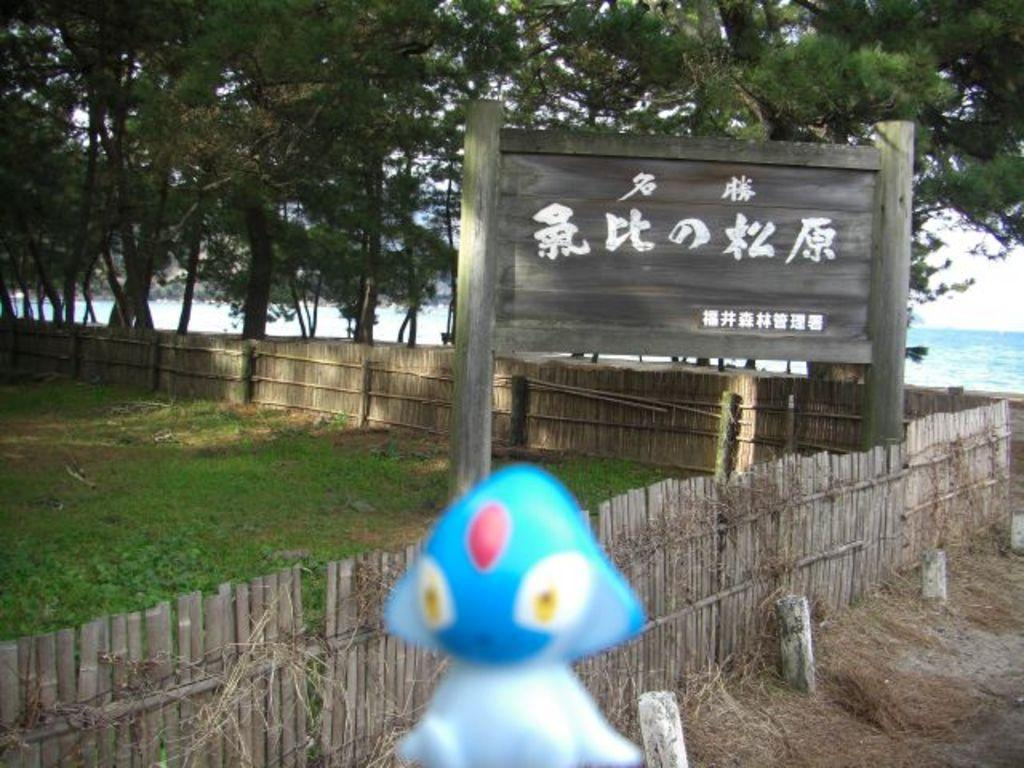What is located in the foreground of the image? In the foreground of the image, there is a toy, a fence, grass, a board, and trees. Can you describe the objects in the foreground? The toy is a prominent object, and there is also a fence, grass, a board, and trees in the foreground. What can be seen in the background of the image? In the background of the image, there is an ocean and the sky. How many different types of natural elements are visible in the image? There are three different types of natural elements visible in the image: grass, trees, and the ocean. Where can you find the receipt for the toy in the image? There is no receipt present in the image. How many beds are visible in the image? There are no beds visible in the image. 